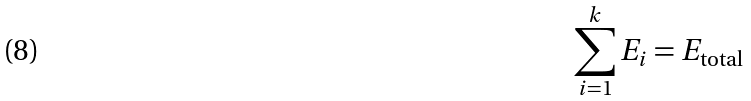Convert formula to latex. <formula><loc_0><loc_0><loc_500><loc_500>\sum _ { i = 1 } ^ { k } E _ { i } = E _ { \text {total} }</formula> 